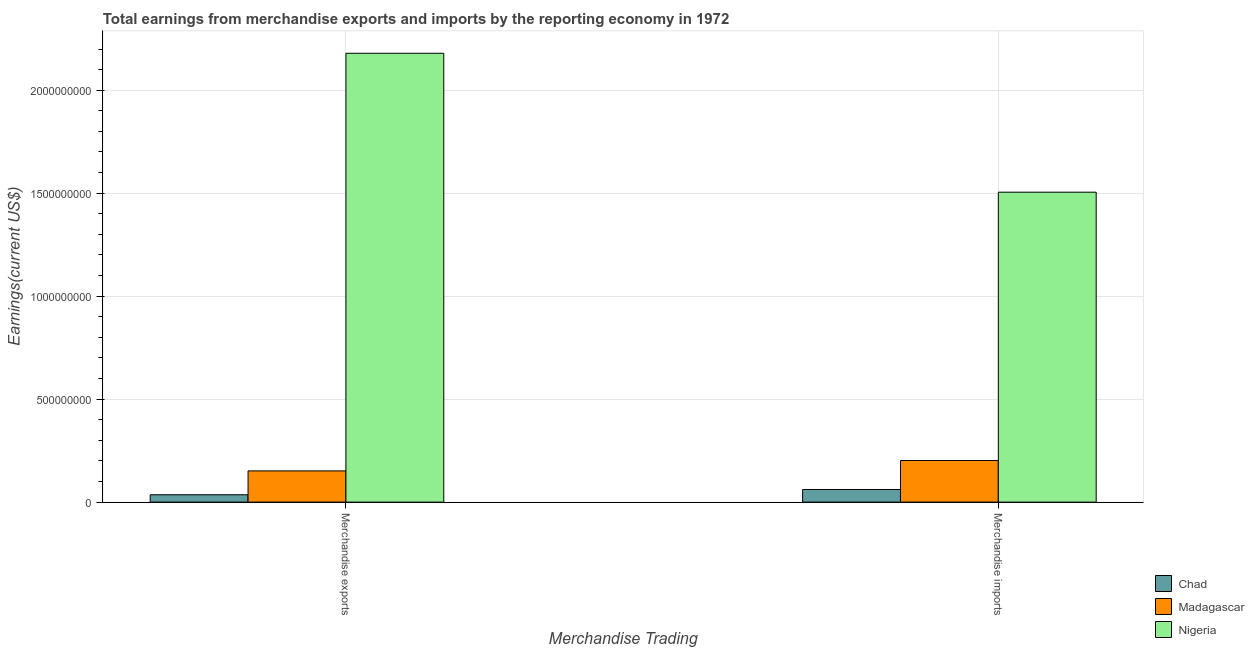How many different coloured bars are there?
Give a very brief answer. 3. How many groups of bars are there?
Offer a terse response. 2. Are the number of bars per tick equal to the number of legend labels?
Make the answer very short. Yes. Are the number of bars on each tick of the X-axis equal?
Your response must be concise. Yes. How many bars are there on the 2nd tick from the right?
Give a very brief answer. 3. What is the label of the 1st group of bars from the left?
Ensure brevity in your answer.  Merchandise exports. What is the earnings from merchandise imports in Madagascar?
Offer a very short reply. 2.02e+08. Across all countries, what is the maximum earnings from merchandise imports?
Your answer should be compact. 1.50e+09. Across all countries, what is the minimum earnings from merchandise imports?
Provide a succinct answer. 6.13e+07. In which country was the earnings from merchandise imports maximum?
Provide a short and direct response. Nigeria. In which country was the earnings from merchandise imports minimum?
Your answer should be compact. Chad. What is the total earnings from merchandise imports in the graph?
Your answer should be compact. 1.77e+09. What is the difference between the earnings from merchandise imports in Nigeria and that in Chad?
Your answer should be compact. 1.44e+09. What is the difference between the earnings from merchandise imports in Madagascar and the earnings from merchandise exports in Chad?
Provide a succinct answer. 1.66e+08. What is the average earnings from merchandise imports per country?
Give a very brief answer. 5.89e+08. What is the difference between the earnings from merchandise exports and earnings from merchandise imports in Madagascar?
Provide a succinct answer. -5.06e+07. What is the ratio of the earnings from merchandise imports in Madagascar to that in Chad?
Offer a very short reply. 3.3. What does the 2nd bar from the left in Merchandise imports represents?
Keep it short and to the point. Madagascar. What does the 3rd bar from the right in Merchandise imports represents?
Offer a terse response. Chad. Are all the bars in the graph horizontal?
Provide a succinct answer. No. What is the difference between two consecutive major ticks on the Y-axis?
Your answer should be very brief. 5.00e+08. Does the graph contain any zero values?
Keep it short and to the point. No. Does the graph contain grids?
Ensure brevity in your answer.  Yes. How many legend labels are there?
Your answer should be compact. 3. What is the title of the graph?
Your response must be concise. Total earnings from merchandise exports and imports by the reporting economy in 1972. Does "Gabon" appear as one of the legend labels in the graph?
Make the answer very short. No. What is the label or title of the X-axis?
Offer a terse response. Merchandise Trading. What is the label or title of the Y-axis?
Your answer should be compact. Earnings(current US$). What is the Earnings(current US$) of Chad in Merchandise exports?
Provide a succinct answer. 3.58e+07. What is the Earnings(current US$) of Madagascar in Merchandise exports?
Your answer should be very brief. 1.52e+08. What is the Earnings(current US$) in Nigeria in Merchandise exports?
Ensure brevity in your answer.  2.18e+09. What is the Earnings(current US$) in Chad in Merchandise imports?
Offer a very short reply. 6.13e+07. What is the Earnings(current US$) of Madagascar in Merchandise imports?
Offer a terse response. 2.02e+08. What is the Earnings(current US$) in Nigeria in Merchandise imports?
Your answer should be compact. 1.50e+09. Across all Merchandise Trading, what is the maximum Earnings(current US$) of Chad?
Provide a short and direct response. 6.13e+07. Across all Merchandise Trading, what is the maximum Earnings(current US$) of Madagascar?
Give a very brief answer. 2.02e+08. Across all Merchandise Trading, what is the maximum Earnings(current US$) of Nigeria?
Provide a short and direct response. 2.18e+09. Across all Merchandise Trading, what is the minimum Earnings(current US$) of Chad?
Give a very brief answer. 3.58e+07. Across all Merchandise Trading, what is the minimum Earnings(current US$) in Madagascar?
Your answer should be very brief. 1.52e+08. Across all Merchandise Trading, what is the minimum Earnings(current US$) of Nigeria?
Your response must be concise. 1.50e+09. What is the total Earnings(current US$) of Chad in the graph?
Ensure brevity in your answer.  9.70e+07. What is the total Earnings(current US$) of Madagascar in the graph?
Provide a short and direct response. 3.54e+08. What is the total Earnings(current US$) of Nigeria in the graph?
Offer a very short reply. 3.68e+09. What is the difference between the Earnings(current US$) in Chad in Merchandise exports and that in Merchandise imports?
Provide a short and direct response. -2.55e+07. What is the difference between the Earnings(current US$) of Madagascar in Merchandise exports and that in Merchandise imports?
Make the answer very short. -5.06e+07. What is the difference between the Earnings(current US$) in Nigeria in Merchandise exports and that in Merchandise imports?
Your response must be concise. 6.74e+08. What is the difference between the Earnings(current US$) in Chad in Merchandise exports and the Earnings(current US$) in Madagascar in Merchandise imports?
Offer a terse response. -1.66e+08. What is the difference between the Earnings(current US$) of Chad in Merchandise exports and the Earnings(current US$) of Nigeria in Merchandise imports?
Ensure brevity in your answer.  -1.47e+09. What is the difference between the Earnings(current US$) of Madagascar in Merchandise exports and the Earnings(current US$) of Nigeria in Merchandise imports?
Provide a short and direct response. -1.35e+09. What is the average Earnings(current US$) of Chad per Merchandise Trading?
Offer a very short reply. 4.85e+07. What is the average Earnings(current US$) of Madagascar per Merchandise Trading?
Your response must be concise. 1.77e+08. What is the average Earnings(current US$) of Nigeria per Merchandise Trading?
Ensure brevity in your answer.  1.84e+09. What is the difference between the Earnings(current US$) in Chad and Earnings(current US$) in Madagascar in Merchandise exports?
Provide a succinct answer. -1.16e+08. What is the difference between the Earnings(current US$) in Chad and Earnings(current US$) in Nigeria in Merchandise exports?
Offer a very short reply. -2.14e+09. What is the difference between the Earnings(current US$) in Madagascar and Earnings(current US$) in Nigeria in Merchandise exports?
Your answer should be very brief. -2.03e+09. What is the difference between the Earnings(current US$) of Chad and Earnings(current US$) of Madagascar in Merchandise imports?
Ensure brevity in your answer.  -1.41e+08. What is the difference between the Earnings(current US$) in Chad and Earnings(current US$) in Nigeria in Merchandise imports?
Your answer should be very brief. -1.44e+09. What is the difference between the Earnings(current US$) of Madagascar and Earnings(current US$) of Nigeria in Merchandise imports?
Provide a short and direct response. -1.30e+09. What is the ratio of the Earnings(current US$) of Chad in Merchandise exports to that in Merchandise imports?
Provide a short and direct response. 0.58. What is the ratio of the Earnings(current US$) of Nigeria in Merchandise exports to that in Merchandise imports?
Your answer should be very brief. 1.45. What is the difference between the highest and the second highest Earnings(current US$) of Chad?
Your answer should be compact. 2.55e+07. What is the difference between the highest and the second highest Earnings(current US$) of Madagascar?
Provide a succinct answer. 5.06e+07. What is the difference between the highest and the second highest Earnings(current US$) of Nigeria?
Your answer should be very brief. 6.74e+08. What is the difference between the highest and the lowest Earnings(current US$) of Chad?
Give a very brief answer. 2.55e+07. What is the difference between the highest and the lowest Earnings(current US$) of Madagascar?
Offer a very short reply. 5.06e+07. What is the difference between the highest and the lowest Earnings(current US$) of Nigeria?
Make the answer very short. 6.74e+08. 